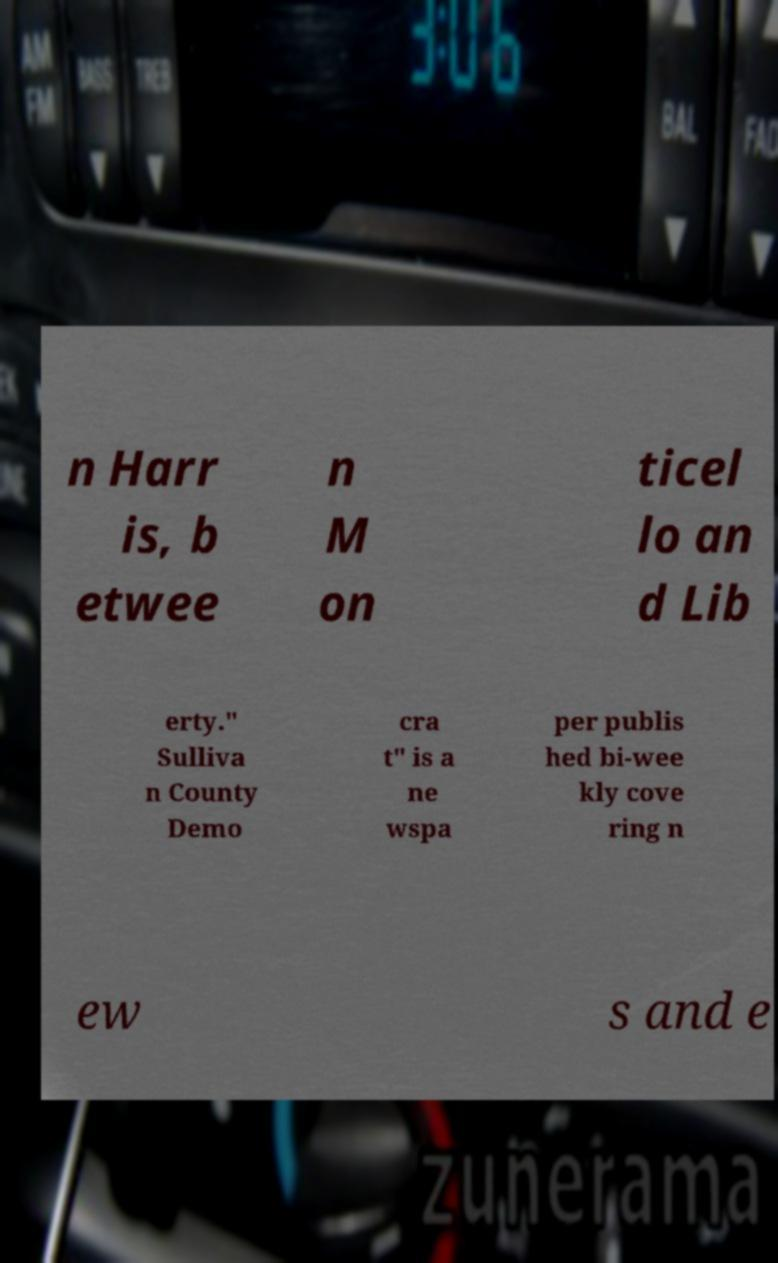What messages or text are displayed in this image? I need them in a readable, typed format. n Harr is, b etwee n M on ticel lo an d Lib erty." Sulliva n County Demo cra t" is a ne wspa per publis hed bi-wee kly cove ring n ew s and e 